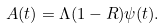<formula> <loc_0><loc_0><loc_500><loc_500>A ( t ) = \Lambda ( 1 - R ) \psi ( t ) .</formula> 